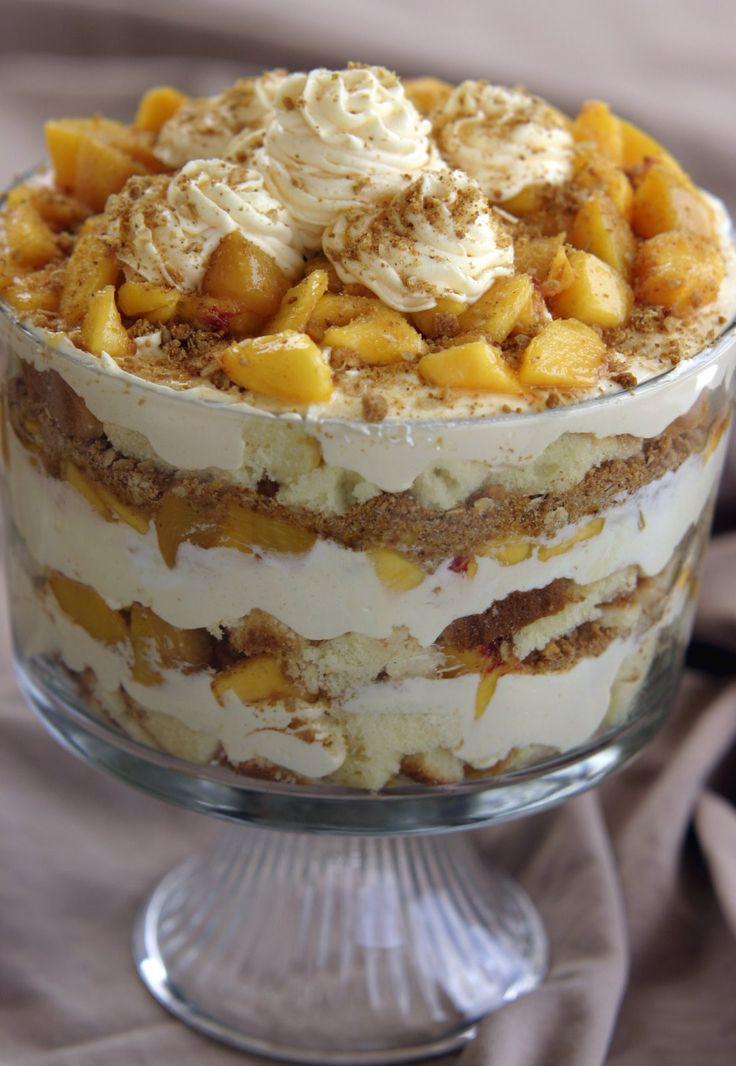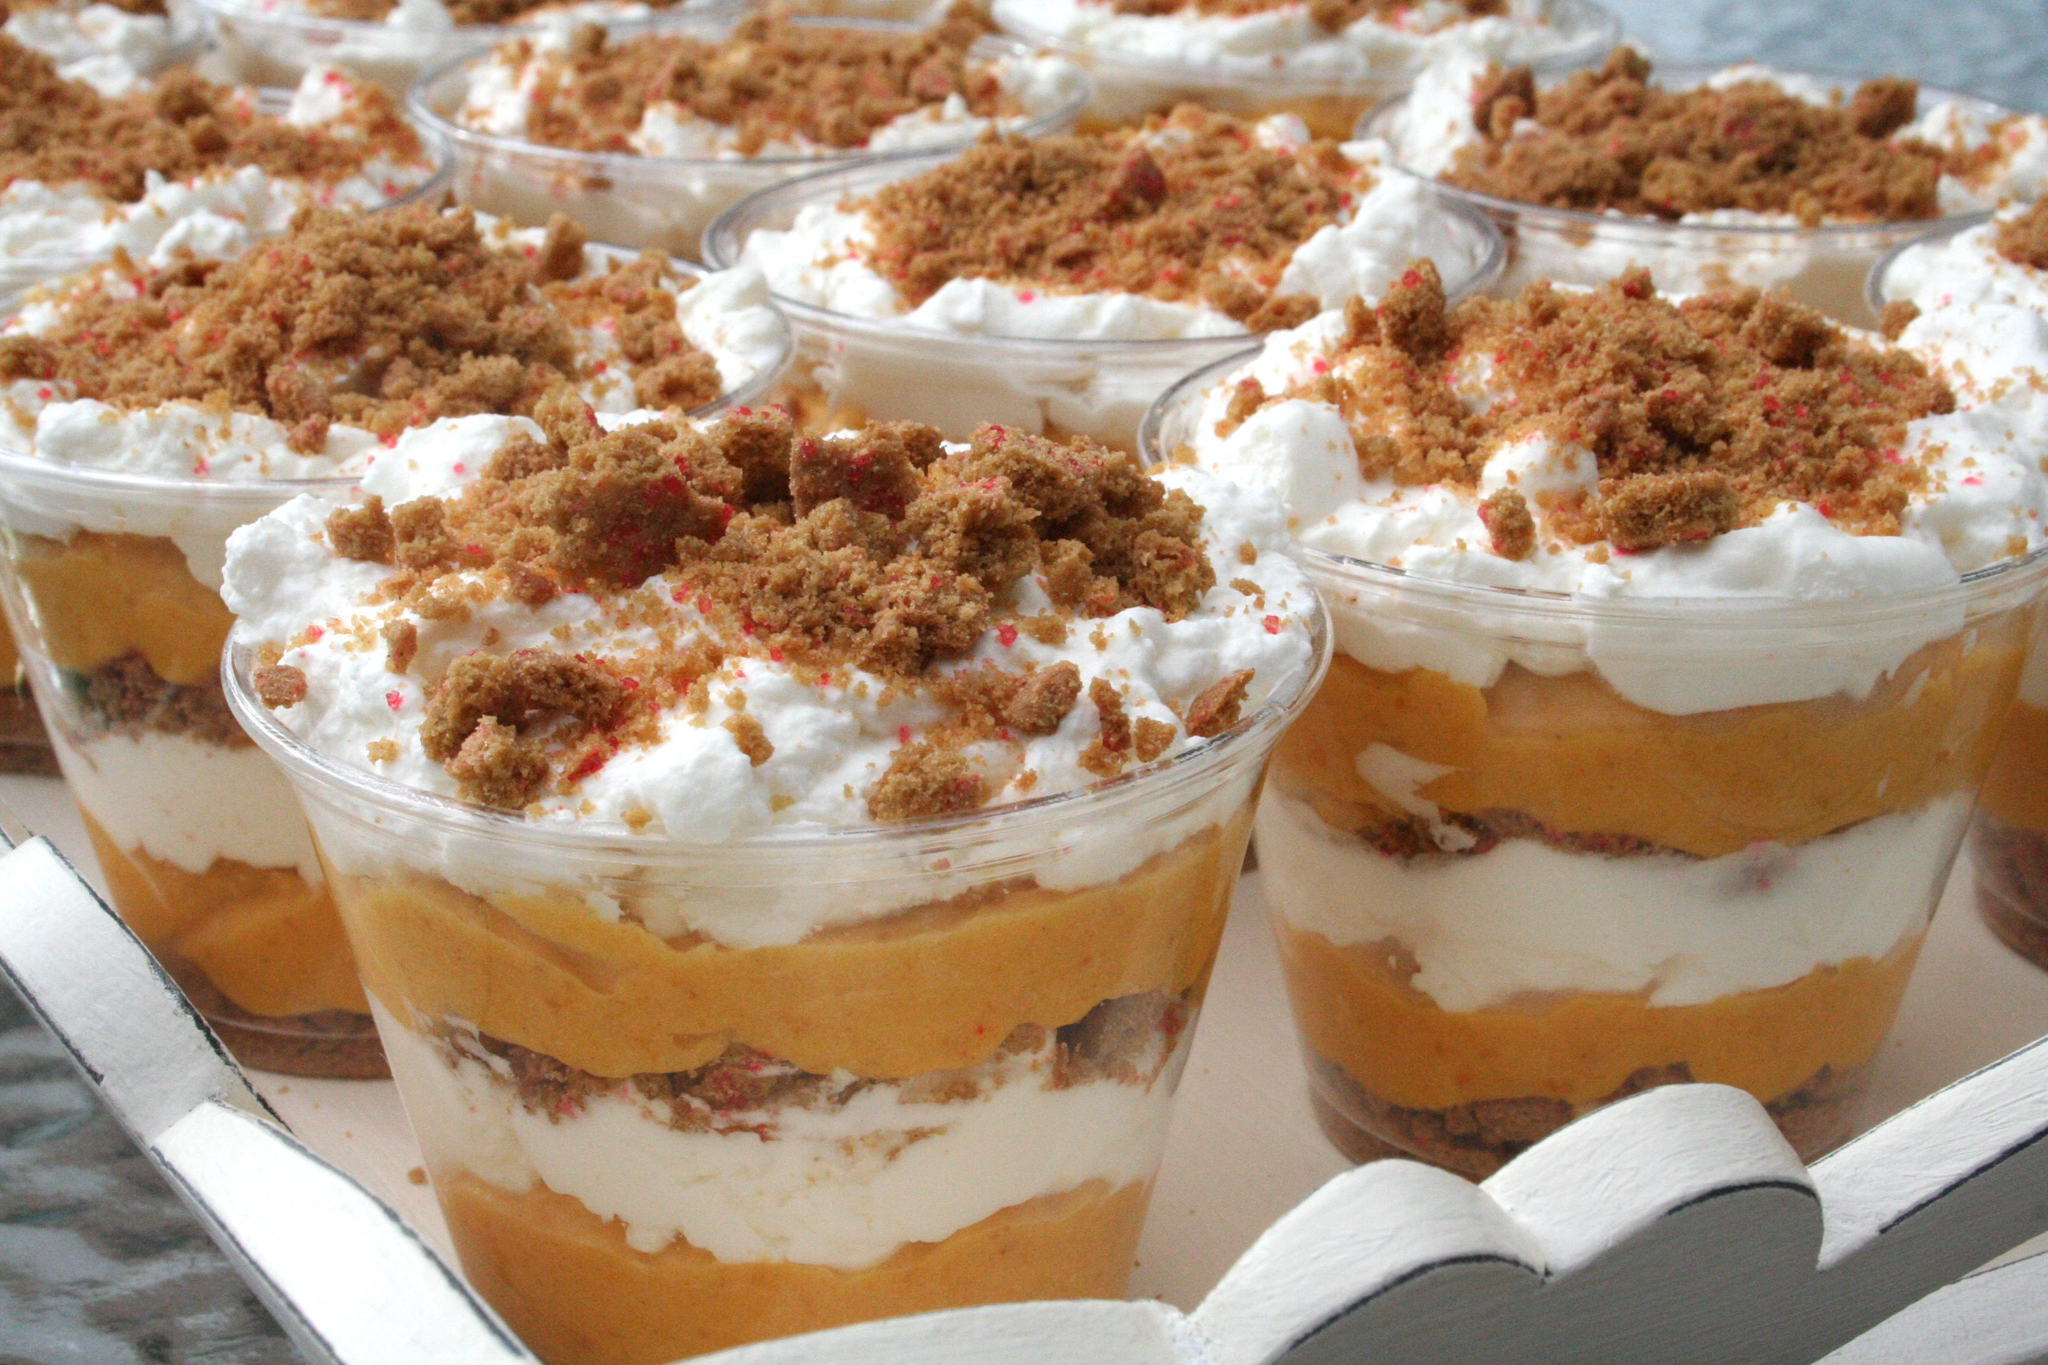The first image is the image on the left, the second image is the image on the right. Assess this claim about the two images: "There are two chocolate parfait and two non chocolate". Correct or not? Answer yes or no. No. The first image is the image on the left, the second image is the image on the right. Evaluate the accuracy of this statement regarding the images: "One image shows at least one fancy individual serving dessert.". Is it true? Answer yes or no. Yes. 